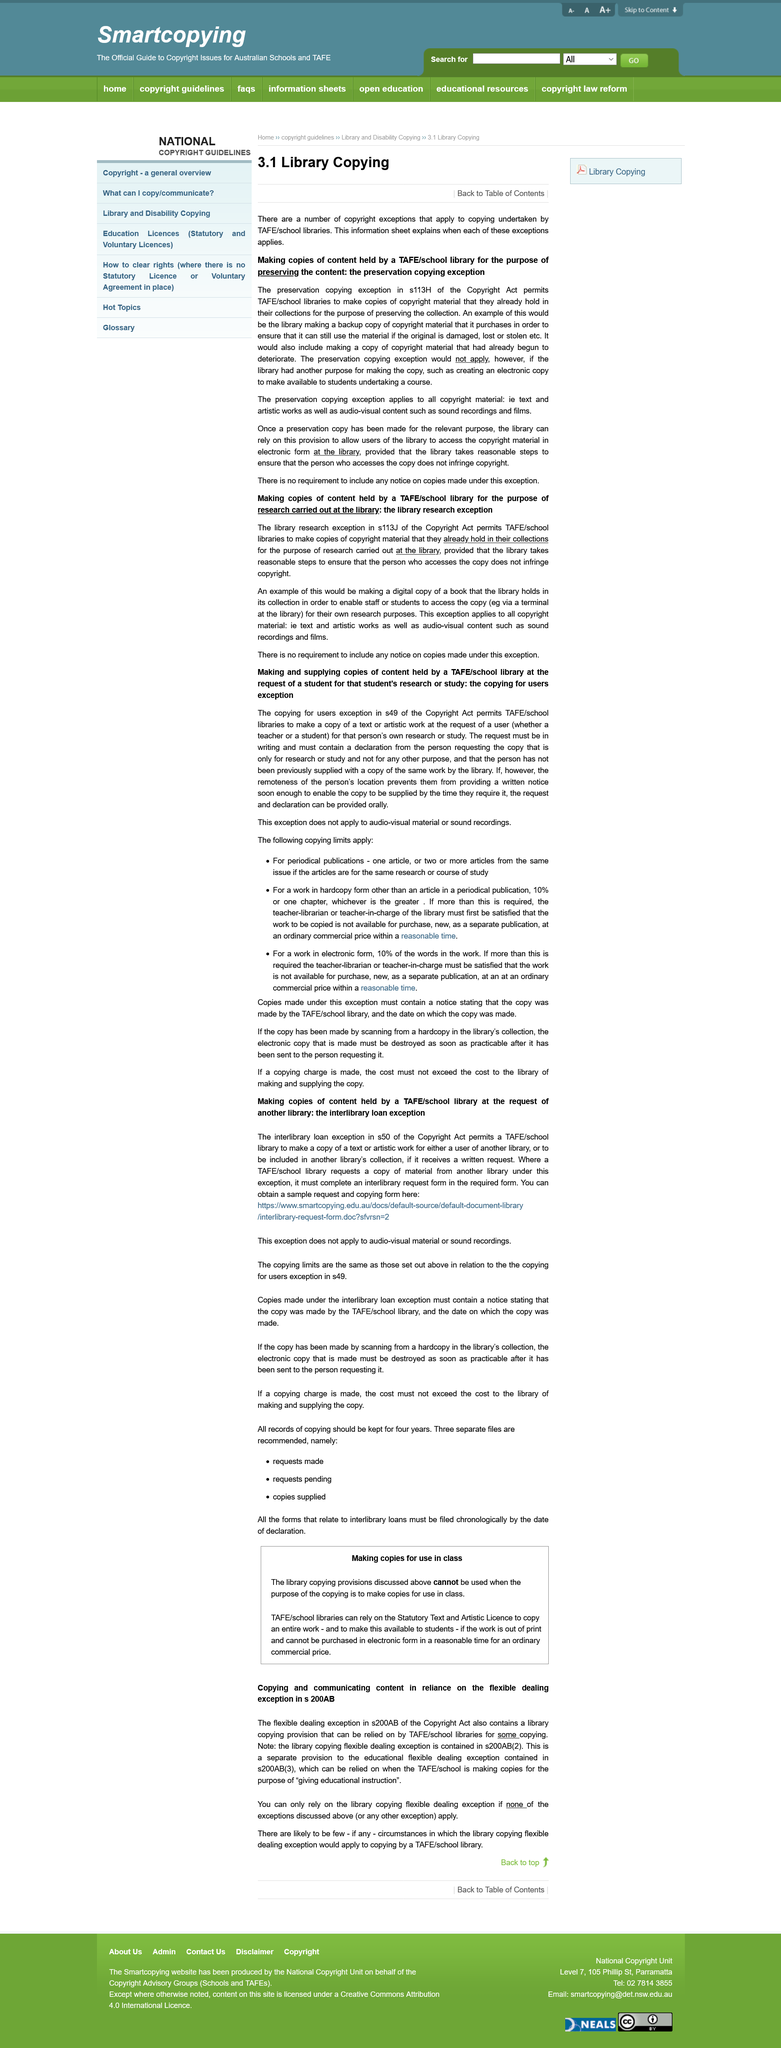Point out several critical features in this image. Under the regulations, periodical publications are permitted a maximum of one article, or two or more articles from the same issue if they are related to the same research or course of study. The library research exception in section 113J of the Copyright Act allows for the making of a digital copy of a book held by the library, in order to enable students to access the copy for their own research purposes. The flexibility of library copying exceptions may be relied upon only when no outlined exceptions apply. The library research exception applies to all copyright material. The restrictions placed on copies include the requirement for a notice stating that it was copied by TAFE/school library with the date, the need to destroy the copy as soon as practical once it has been sent, and the charge for the copy being no more than what it costs TAFE/school library to produce it. 